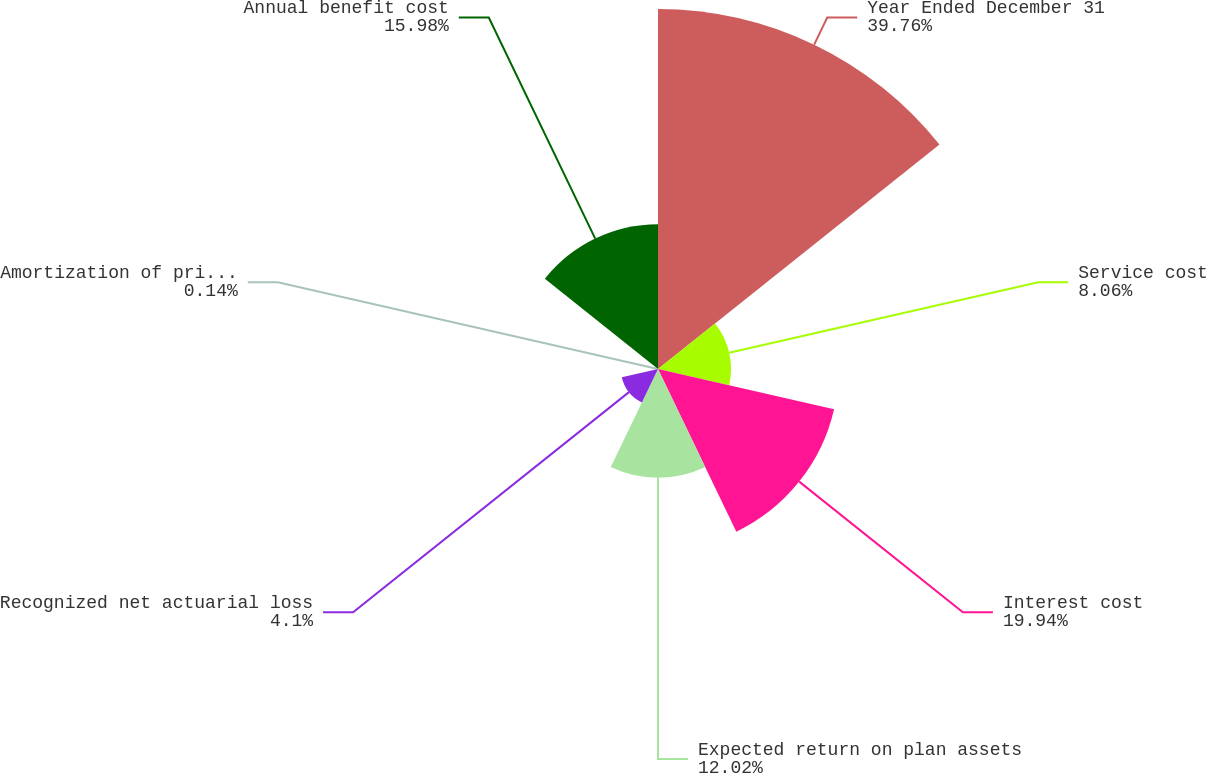Convert chart. <chart><loc_0><loc_0><loc_500><loc_500><pie_chart><fcel>Year Ended December 31<fcel>Service cost<fcel>Interest cost<fcel>Expected return on plan assets<fcel>Recognized net actuarial loss<fcel>Amortization of prior service<fcel>Annual benefit cost<nl><fcel>39.75%<fcel>8.06%<fcel>19.94%<fcel>12.02%<fcel>4.1%<fcel>0.14%<fcel>15.98%<nl></chart> 